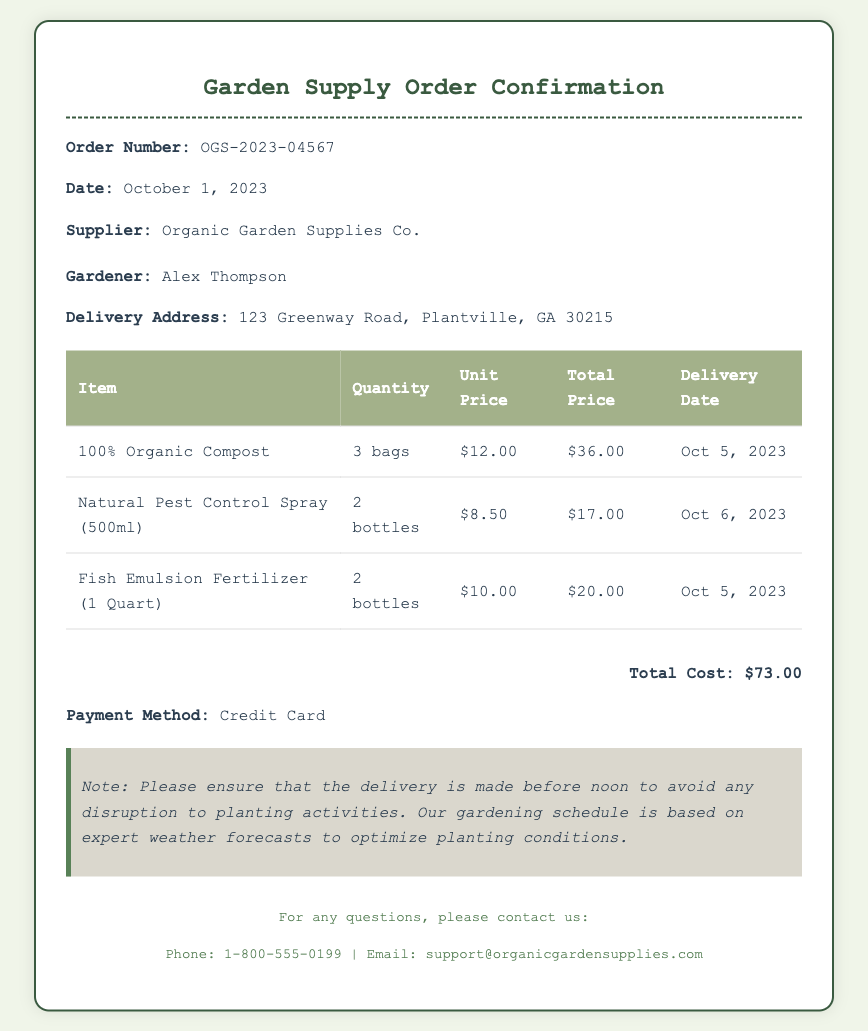What is the order number? The order number is a unique identifier for the transaction, listed as OGS-2023-04567.
Answer: OGS-2023-04567 What is the total cost of the order? The total cost is calculated by summing the total prices of all items listed, which equals $73.00.
Answer: $73.00 What delivery date is specified for the Fish Emulsion Fertilizer? This information can be found in the delivery date column for this specific item, which is Oct 5, 2023.
Answer: Oct 5, 2023 Who is the supplier? The supplier's name is mentioned in the order details section, which is Organic Garden Supplies Co.
Answer: Organic Garden Supplies Co How many bottles of Natural Pest Control Spray were ordered? The quantity ordered for the Natural Pest Control Spray is specified in the document, which is 2 bottles.
Answer: 2 bottles When is the delivery date for the compost? The delivery date for the compost is provided in the item list, which is Oct 5, 2023.
Answer: Oct 5, 2023 What is the payment method used for this order? The document states the payment method, which is Credit Card.
Answer: Credit Card What is the gardener's name? The name of the gardener is stated in the customer details section, which is Alex Thompson.
Answer: Alex Thompson What should the delivery time be to avoid disruption? This information is provided in a note about the delivery timing related to planting activities, which states before noon.
Answer: before noon 